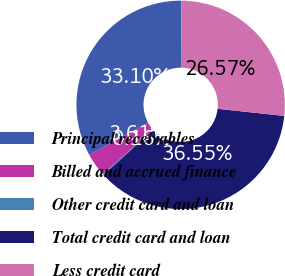Convert chart. <chart><loc_0><loc_0><loc_500><loc_500><pie_chart><fcel>Principal receivables<fcel>Billed and accrued finance<fcel>Other credit card and loan<fcel>Total credit card and loan<fcel>Less credit card<nl><fcel>33.1%<fcel>3.61%<fcel>0.16%<fcel>36.55%<fcel>26.57%<nl></chart> 